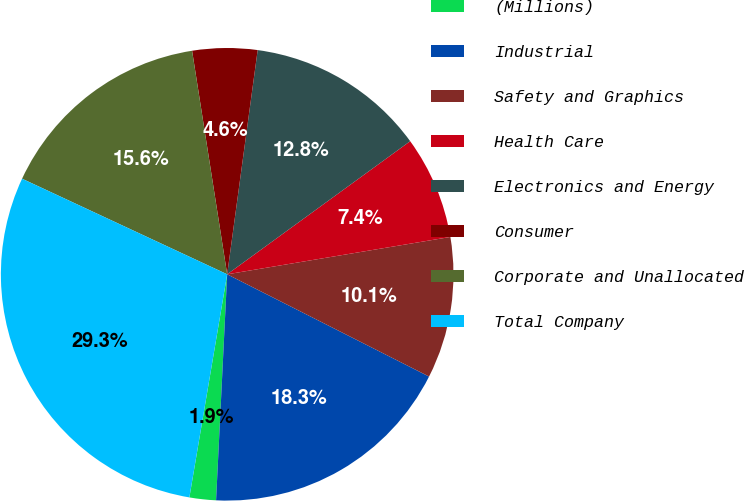Convert chart. <chart><loc_0><loc_0><loc_500><loc_500><pie_chart><fcel>(Millions)<fcel>Industrial<fcel>Safety and Graphics<fcel>Health Care<fcel>Electronics and Energy<fcel>Consumer<fcel>Corporate and Unallocated<fcel>Total Company<nl><fcel>1.89%<fcel>18.32%<fcel>10.1%<fcel>7.37%<fcel>12.84%<fcel>4.63%<fcel>15.58%<fcel>29.27%<nl></chart> 